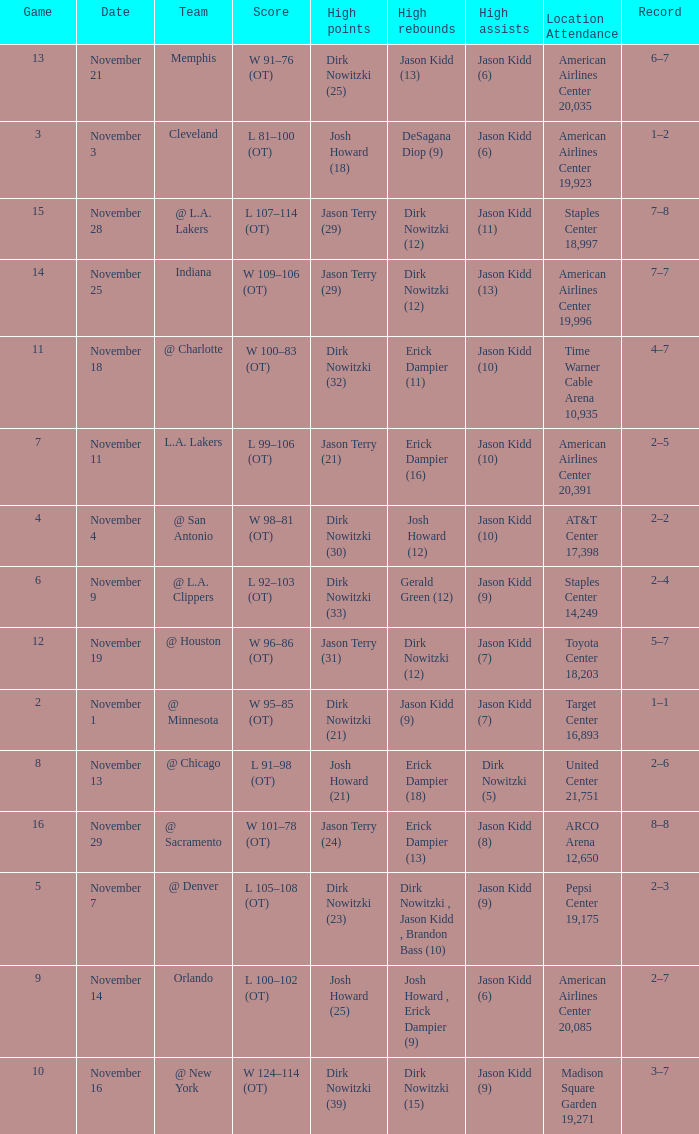What is High Rebounds, when High Assists is "Jason Kidd (13)"? Dirk Nowitzki (12). 